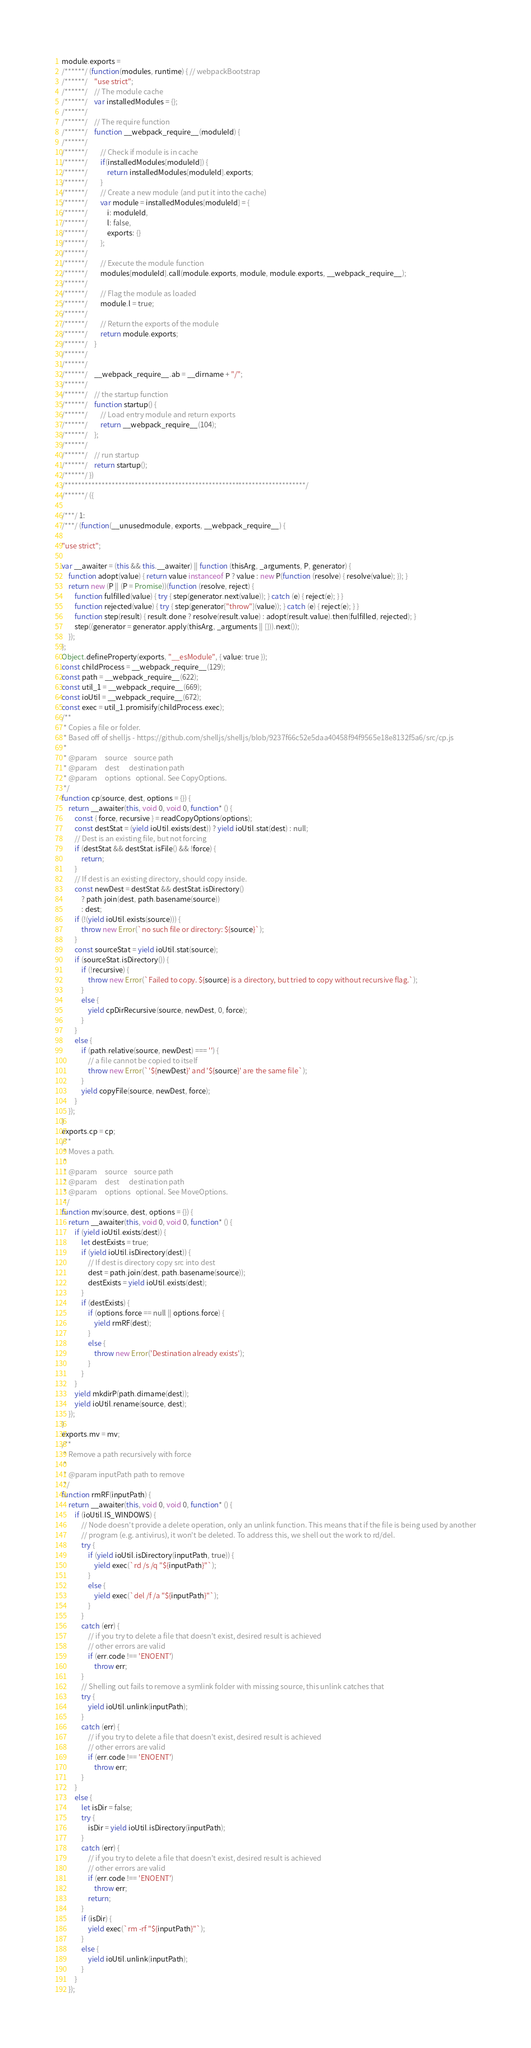<code> <loc_0><loc_0><loc_500><loc_500><_JavaScript_>module.exports =
/******/ (function(modules, runtime) { // webpackBootstrap
/******/ 	"use strict";
/******/ 	// The module cache
/******/ 	var installedModules = {};
/******/
/******/ 	// The require function
/******/ 	function __webpack_require__(moduleId) {
/******/
/******/ 		// Check if module is in cache
/******/ 		if(installedModules[moduleId]) {
/******/ 			return installedModules[moduleId].exports;
/******/ 		}
/******/ 		// Create a new module (and put it into the cache)
/******/ 		var module = installedModules[moduleId] = {
/******/ 			i: moduleId,
/******/ 			l: false,
/******/ 			exports: {}
/******/ 		};
/******/
/******/ 		// Execute the module function
/******/ 		modules[moduleId].call(module.exports, module, module.exports, __webpack_require__);
/******/
/******/ 		// Flag the module as loaded
/******/ 		module.l = true;
/******/
/******/ 		// Return the exports of the module
/******/ 		return module.exports;
/******/ 	}
/******/
/******/
/******/ 	__webpack_require__.ab = __dirname + "/";
/******/
/******/ 	// the startup function
/******/ 	function startup() {
/******/ 		// Load entry module and return exports
/******/ 		return __webpack_require__(104);
/******/ 	};
/******/
/******/ 	// run startup
/******/ 	return startup();
/******/ })
/************************************************************************/
/******/ ({

/***/ 1:
/***/ (function(__unusedmodule, exports, __webpack_require__) {

"use strict";

var __awaiter = (this && this.__awaiter) || function (thisArg, _arguments, P, generator) {
    function adopt(value) { return value instanceof P ? value : new P(function (resolve) { resolve(value); }); }
    return new (P || (P = Promise))(function (resolve, reject) {
        function fulfilled(value) { try { step(generator.next(value)); } catch (e) { reject(e); } }
        function rejected(value) { try { step(generator["throw"](value)); } catch (e) { reject(e); } }
        function step(result) { result.done ? resolve(result.value) : adopt(result.value).then(fulfilled, rejected); }
        step((generator = generator.apply(thisArg, _arguments || [])).next());
    });
};
Object.defineProperty(exports, "__esModule", { value: true });
const childProcess = __webpack_require__(129);
const path = __webpack_require__(622);
const util_1 = __webpack_require__(669);
const ioUtil = __webpack_require__(672);
const exec = util_1.promisify(childProcess.exec);
/**
 * Copies a file or folder.
 * Based off of shelljs - https://github.com/shelljs/shelljs/blob/9237f66c52e5daa40458f94f9565e18e8132f5a6/src/cp.js
 *
 * @param     source    source path
 * @param     dest      destination path
 * @param     options   optional. See CopyOptions.
 */
function cp(source, dest, options = {}) {
    return __awaiter(this, void 0, void 0, function* () {
        const { force, recursive } = readCopyOptions(options);
        const destStat = (yield ioUtil.exists(dest)) ? yield ioUtil.stat(dest) : null;
        // Dest is an existing file, but not forcing
        if (destStat && destStat.isFile() && !force) {
            return;
        }
        // If dest is an existing directory, should copy inside.
        const newDest = destStat && destStat.isDirectory()
            ? path.join(dest, path.basename(source))
            : dest;
        if (!(yield ioUtil.exists(source))) {
            throw new Error(`no such file or directory: ${source}`);
        }
        const sourceStat = yield ioUtil.stat(source);
        if (sourceStat.isDirectory()) {
            if (!recursive) {
                throw new Error(`Failed to copy. ${source} is a directory, but tried to copy without recursive flag.`);
            }
            else {
                yield cpDirRecursive(source, newDest, 0, force);
            }
        }
        else {
            if (path.relative(source, newDest) === '') {
                // a file cannot be copied to itself
                throw new Error(`'${newDest}' and '${source}' are the same file`);
            }
            yield copyFile(source, newDest, force);
        }
    });
}
exports.cp = cp;
/**
 * Moves a path.
 *
 * @param     source    source path
 * @param     dest      destination path
 * @param     options   optional. See MoveOptions.
 */
function mv(source, dest, options = {}) {
    return __awaiter(this, void 0, void 0, function* () {
        if (yield ioUtil.exists(dest)) {
            let destExists = true;
            if (yield ioUtil.isDirectory(dest)) {
                // If dest is directory copy src into dest
                dest = path.join(dest, path.basename(source));
                destExists = yield ioUtil.exists(dest);
            }
            if (destExists) {
                if (options.force == null || options.force) {
                    yield rmRF(dest);
                }
                else {
                    throw new Error('Destination already exists');
                }
            }
        }
        yield mkdirP(path.dirname(dest));
        yield ioUtil.rename(source, dest);
    });
}
exports.mv = mv;
/**
 * Remove a path recursively with force
 *
 * @param inputPath path to remove
 */
function rmRF(inputPath) {
    return __awaiter(this, void 0, void 0, function* () {
        if (ioUtil.IS_WINDOWS) {
            // Node doesn't provide a delete operation, only an unlink function. This means that if the file is being used by another
            // program (e.g. antivirus), it won't be deleted. To address this, we shell out the work to rd/del.
            try {
                if (yield ioUtil.isDirectory(inputPath, true)) {
                    yield exec(`rd /s /q "${inputPath}"`);
                }
                else {
                    yield exec(`del /f /a "${inputPath}"`);
                }
            }
            catch (err) {
                // if you try to delete a file that doesn't exist, desired result is achieved
                // other errors are valid
                if (err.code !== 'ENOENT')
                    throw err;
            }
            // Shelling out fails to remove a symlink folder with missing source, this unlink catches that
            try {
                yield ioUtil.unlink(inputPath);
            }
            catch (err) {
                // if you try to delete a file that doesn't exist, desired result is achieved
                // other errors are valid
                if (err.code !== 'ENOENT')
                    throw err;
            }
        }
        else {
            let isDir = false;
            try {
                isDir = yield ioUtil.isDirectory(inputPath);
            }
            catch (err) {
                // if you try to delete a file that doesn't exist, desired result is achieved
                // other errors are valid
                if (err.code !== 'ENOENT')
                    throw err;
                return;
            }
            if (isDir) {
                yield exec(`rm -rf "${inputPath}"`);
            }
            else {
                yield ioUtil.unlink(inputPath);
            }
        }
    });</code> 